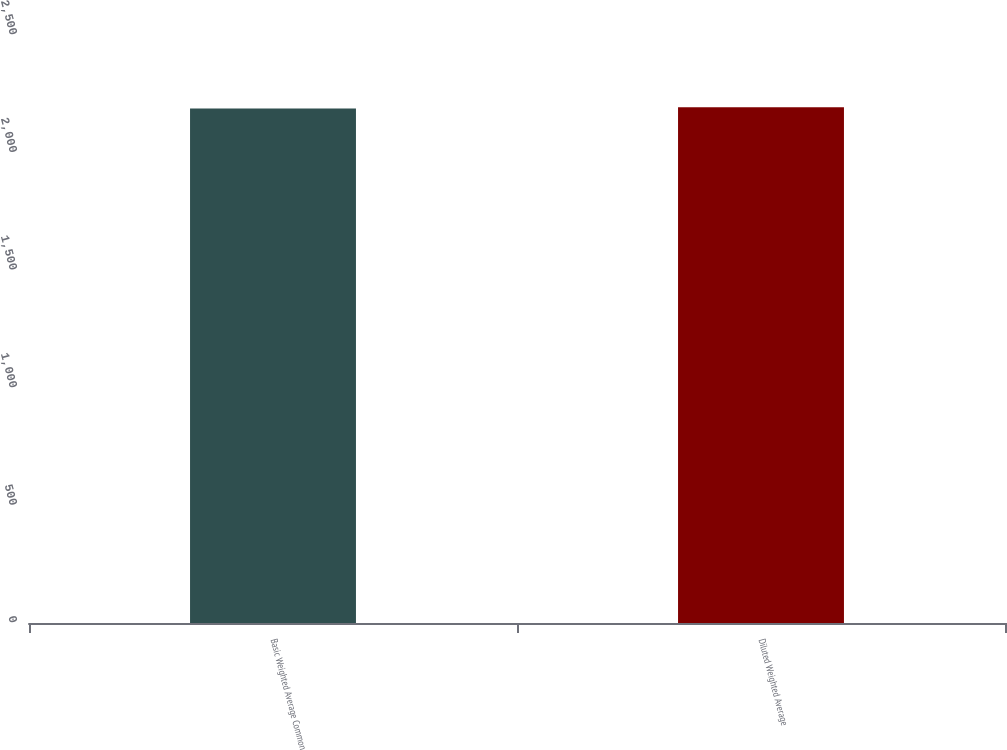Convert chart. <chart><loc_0><loc_0><loc_500><loc_500><bar_chart><fcel>Basic Weighted Average Common<fcel>Diluted Weighted Average<nl><fcel>2187<fcel>2193<nl></chart> 